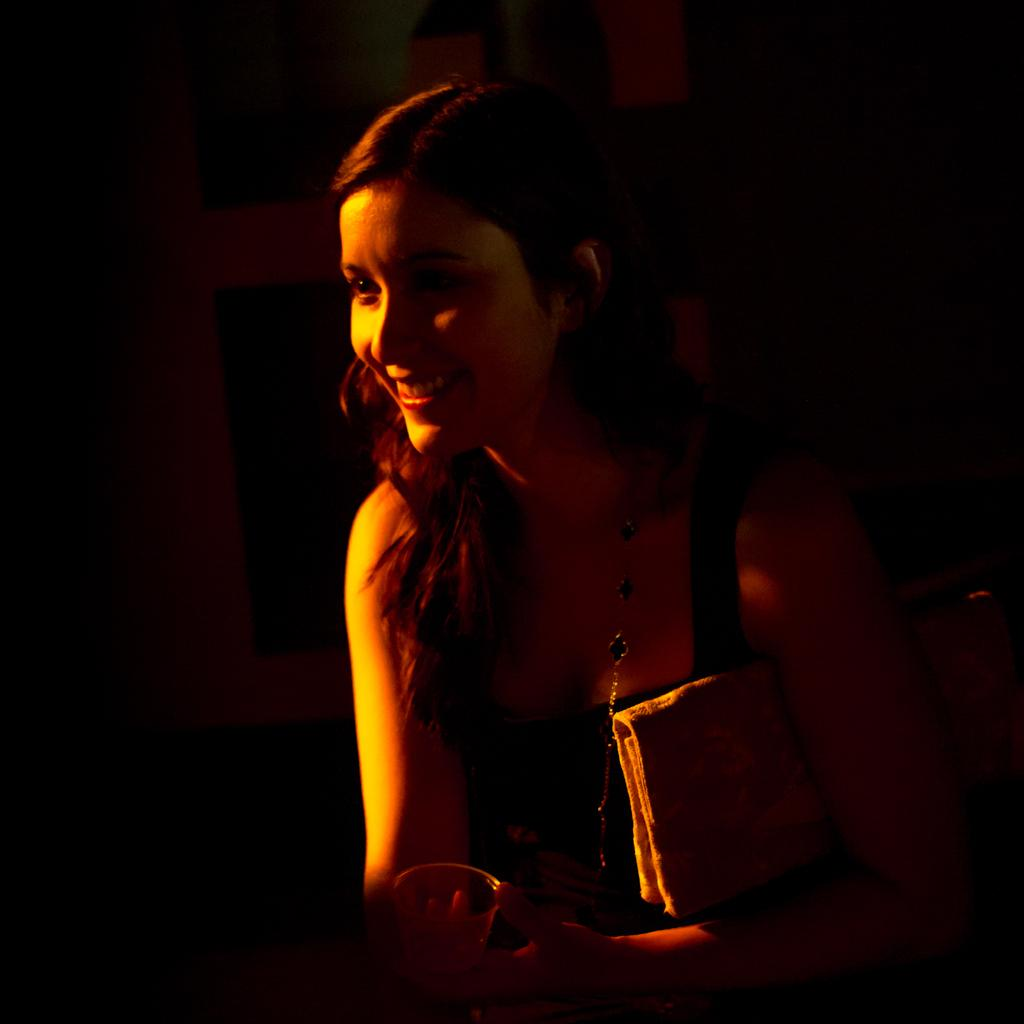Who is the main subject in the image? There is a woman in the image. What is the woman holding in her hand? The woman is holding a glass and a handbag. What is the woman's facial expression in the image? The woman is smiling. How would you describe the background of the image? The background of the image is dark in color. How does the woman plan to increase the size of the group in the image? There is no mention of a group or any intention to increase its size in the image. 